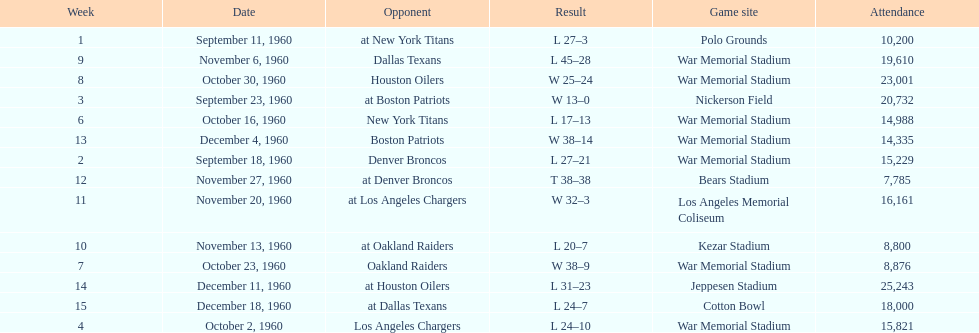What were the total number of games played in november? 4. 